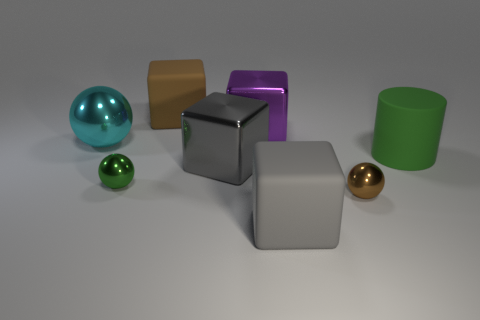Do the rubber thing behind the big cylinder and the metallic sphere that is to the right of the large purple metal block have the same color?
Your answer should be compact. Yes. There is a purple block that is the same material as the large cyan thing; what is its size?
Offer a terse response. Large. What is the color of the rubber object that is behind the brown sphere and in front of the big shiny sphere?
Your response must be concise. Green. Is the shape of the green thing that is on the left side of the big brown block the same as the brown object in front of the cylinder?
Your response must be concise. Yes. There is a cyan sphere behind the tiny brown metal thing; what is it made of?
Your answer should be very brief. Metal. The shiny object that is the same color as the cylinder is what size?
Offer a terse response. Small. What number of things are large blocks that are behind the large cyan ball or large cyan shiny objects?
Your answer should be very brief. 3. Is the number of brown objects in front of the large cylinder the same as the number of big rubber blocks?
Give a very brief answer. No. Is the size of the rubber cylinder the same as the gray matte cube?
Your response must be concise. Yes. The shiny ball that is the same size as the green cylinder is what color?
Keep it short and to the point. Cyan. 